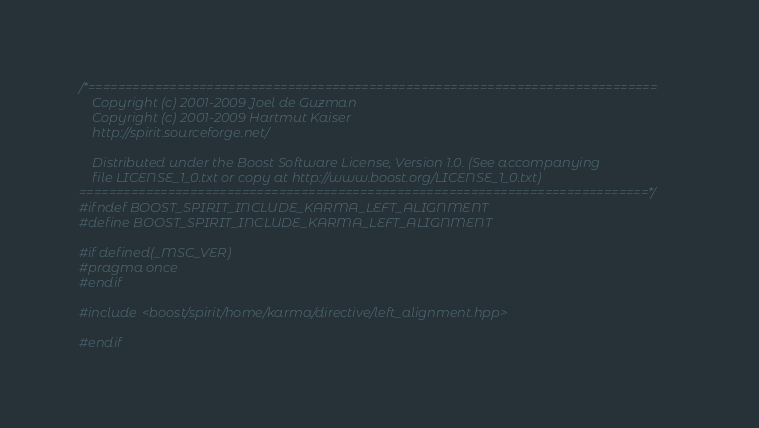Convert code to text. <code><loc_0><loc_0><loc_500><loc_500><_C++_>/*=============================================================================
    Copyright (c) 2001-2009 Joel de Guzman
    Copyright (c) 2001-2009 Hartmut Kaiser
    http://spirit.sourceforge.net/

    Distributed under the Boost Software License, Version 1.0. (See accompanying
    file LICENSE_1_0.txt or copy at http://www.boost.org/LICENSE_1_0.txt)
=============================================================================*/
#ifndef BOOST_SPIRIT_INCLUDE_KARMA_LEFT_ALIGNMENT
#define BOOST_SPIRIT_INCLUDE_KARMA_LEFT_ALIGNMENT

#if defined(_MSC_VER)
#pragma once
#endif

#include <boost/spirit/home/karma/directive/left_alignment.hpp>

#endif
</code> 